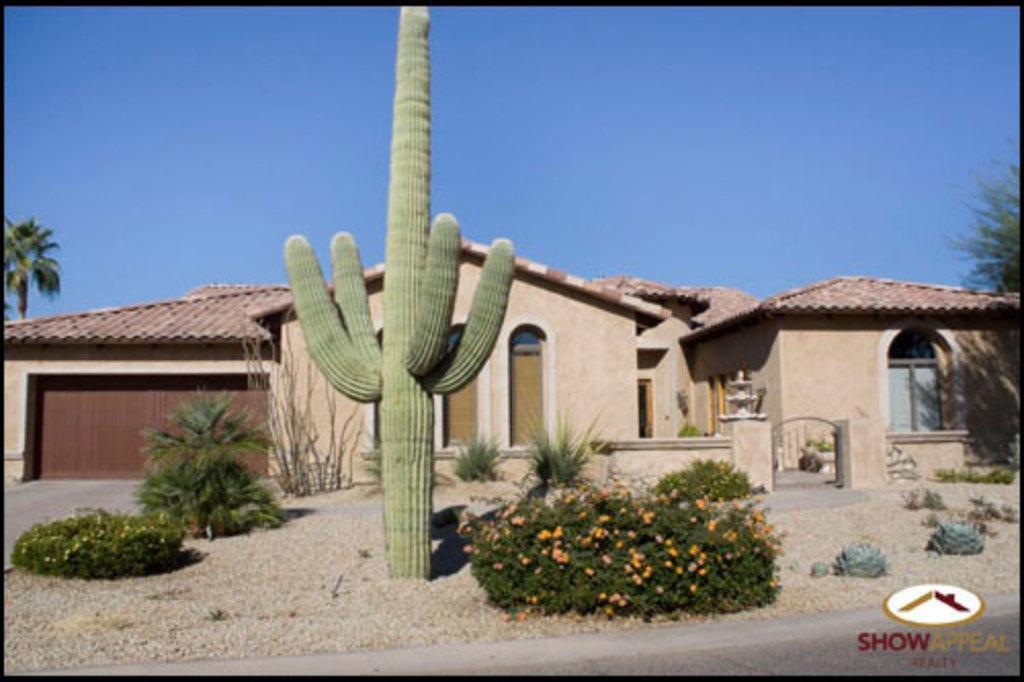How would you summarize this image in a sentence or two? In this image, we can see some plants. There is a shelter house in the middle of the image. There is a sky at the top of the image. 